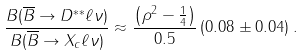<formula> <loc_0><loc_0><loc_500><loc_500>\frac { B ( \overline { B } \rightarrow D ^ { * * } \ell \nu ) } { B ( \overline { B } \rightarrow X _ { c } \ell \nu ) } \approx \frac { \left ( \rho ^ { 2 } - \frac { 1 } { 4 } \right ) } { 0 . 5 } \, ( 0 . 0 8 \pm 0 . 0 4 ) \, .</formula> 